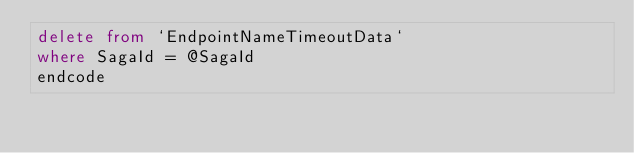<code> <loc_0><loc_0><loc_500><loc_500><_SQL_>delete from `EndpointNameTimeoutData`
where SagaId = @SagaId
endcode
</code> 